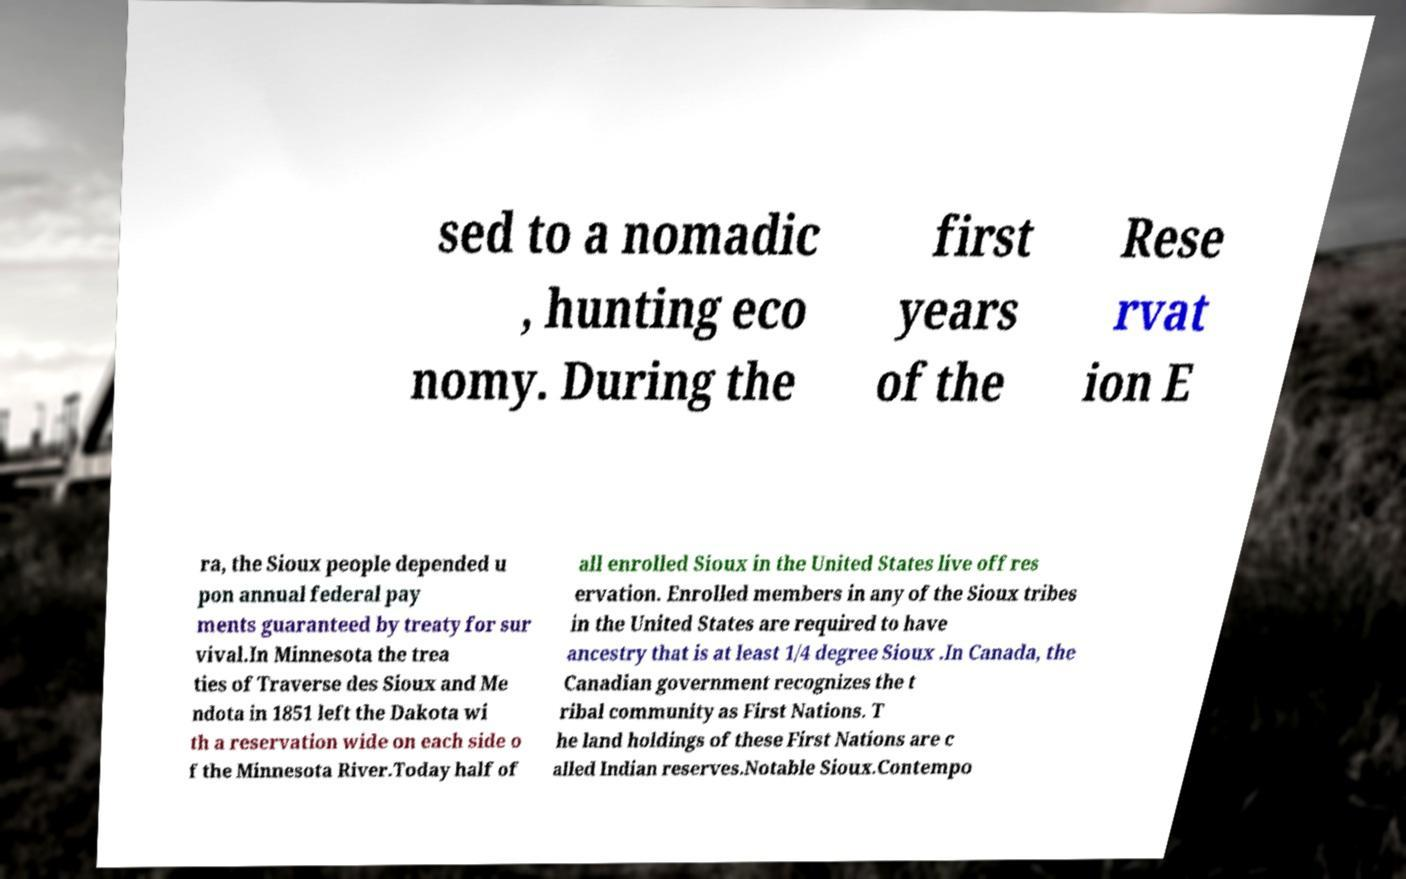What messages or text are displayed in this image? I need them in a readable, typed format. sed to a nomadic , hunting eco nomy. During the first years of the Rese rvat ion E ra, the Sioux people depended u pon annual federal pay ments guaranteed by treaty for sur vival.In Minnesota the trea ties of Traverse des Sioux and Me ndota in 1851 left the Dakota wi th a reservation wide on each side o f the Minnesota River.Today half of all enrolled Sioux in the United States live off res ervation. Enrolled members in any of the Sioux tribes in the United States are required to have ancestry that is at least 1/4 degree Sioux .In Canada, the Canadian government recognizes the t ribal community as First Nations. T he land holdings of these First Nations are c alled Indian reserves.Notable Sioux.Contempo 